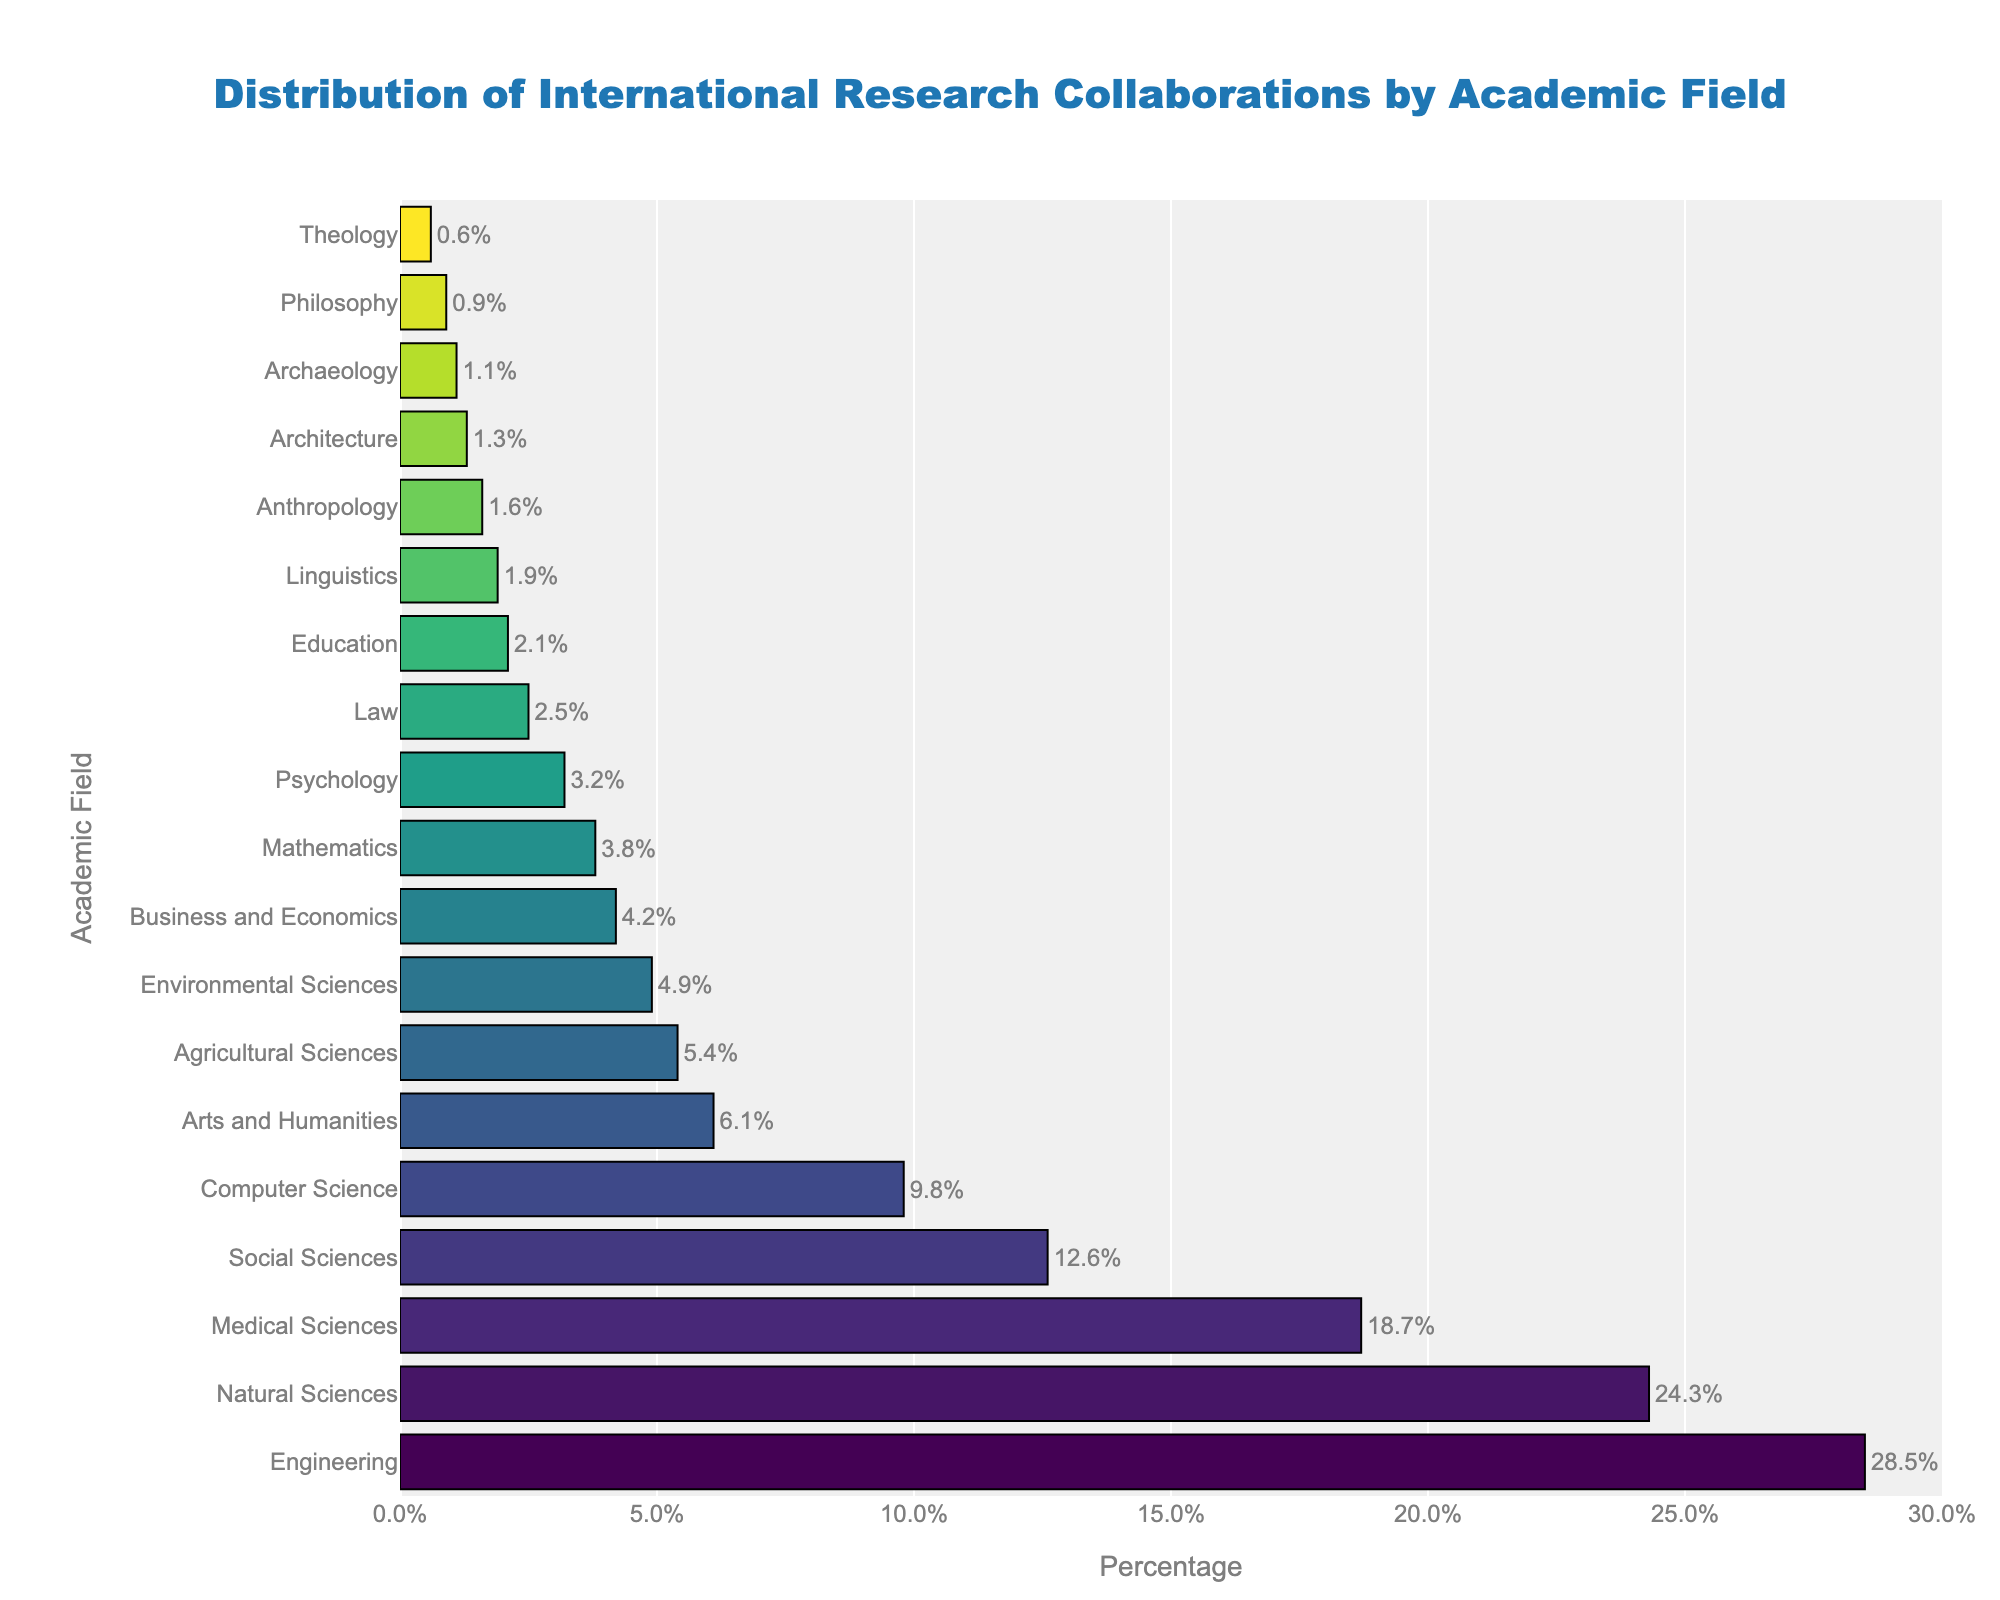What academic field has the highest percentage of international research collaborations? According to the bar chart, the field with the longest bar represents the highest percentage of international research collaborations. This is the Engineering field.
Answer: Engineering What is the combined percentage of international research collaborations for Social Sciences and Computer Science? By locating and adding the percentages for Social Sciences (12.6%) and Computer Science (9.8%) from the bar chart, the sum is 12.6% + 9.8% = 22.4%.
Answer: 22.4% Which field has a greater percentage of international research collaborations: Agricultural Sciences or Environmental Sciences? By comparing the bar lengths, the Agricultural Sciences field has a longer bar representing 5.4%, whereas the Environmental Sciences field has a bar representing 4.9%. Therefore, Agricultural Sciences has a greater percentage.
Answer: Agricultural Sciences How much greater is the percentage of international research collaborations in Medical Sciences compared to Psychology? The Medical Sciences field has 18.7% and the Psychology field has 3.2%. The difference is 18.7% - 3.2% = 15.5%.
Answer: 15.5% What is the average percentage of the top three academic fields with the highest international research collaborations? The top three fields are Engineering (28.5%), Natural Sciences (24.3%), and Medical Sciences (18.7%). The average is calculated by (28.5 + 24.3 + 18.7) / 3 = 71.5 / 3 = 23.83%.
Answer: 23.83% Is the percentage of international research collaborations in the Arts and Humanities field greater than or less than 10%? The bar for the Arts and Humanities field shows a value of 6.1%. This is less than 10%.
Answer: Less than 10% Which field has a lower percentage of international research collaborations: Mathematics or Anthropology? According to the bar chart, Mathematics has a percentage of 3.8% and Anthropology has 1.6%. Therefore, Anthropology has a lower percentage.
Answer: Anthropology What is the approximate total percentage of international research collaborations in Business and Economics, Education, and Linguistics combined? By summing the percentages for Business and Economics (4.2%), Education (2.1%), and Linguistics (1.9%), the total is approximately 4.2% + 2.1% + 1.9% = 8.2%.
Answer: 8.2% Which academic field has the closest percentage to the median value of all the fields listed? By listing all the percentages, the median value falls in the middle of the sorted percentages. In this list, it is between 3.8% (Mathematics) and 4.2% (Business and Economics), so the closest field to the median percentage is Business and Economics with 4.2%.
Answer: Business and Economics 